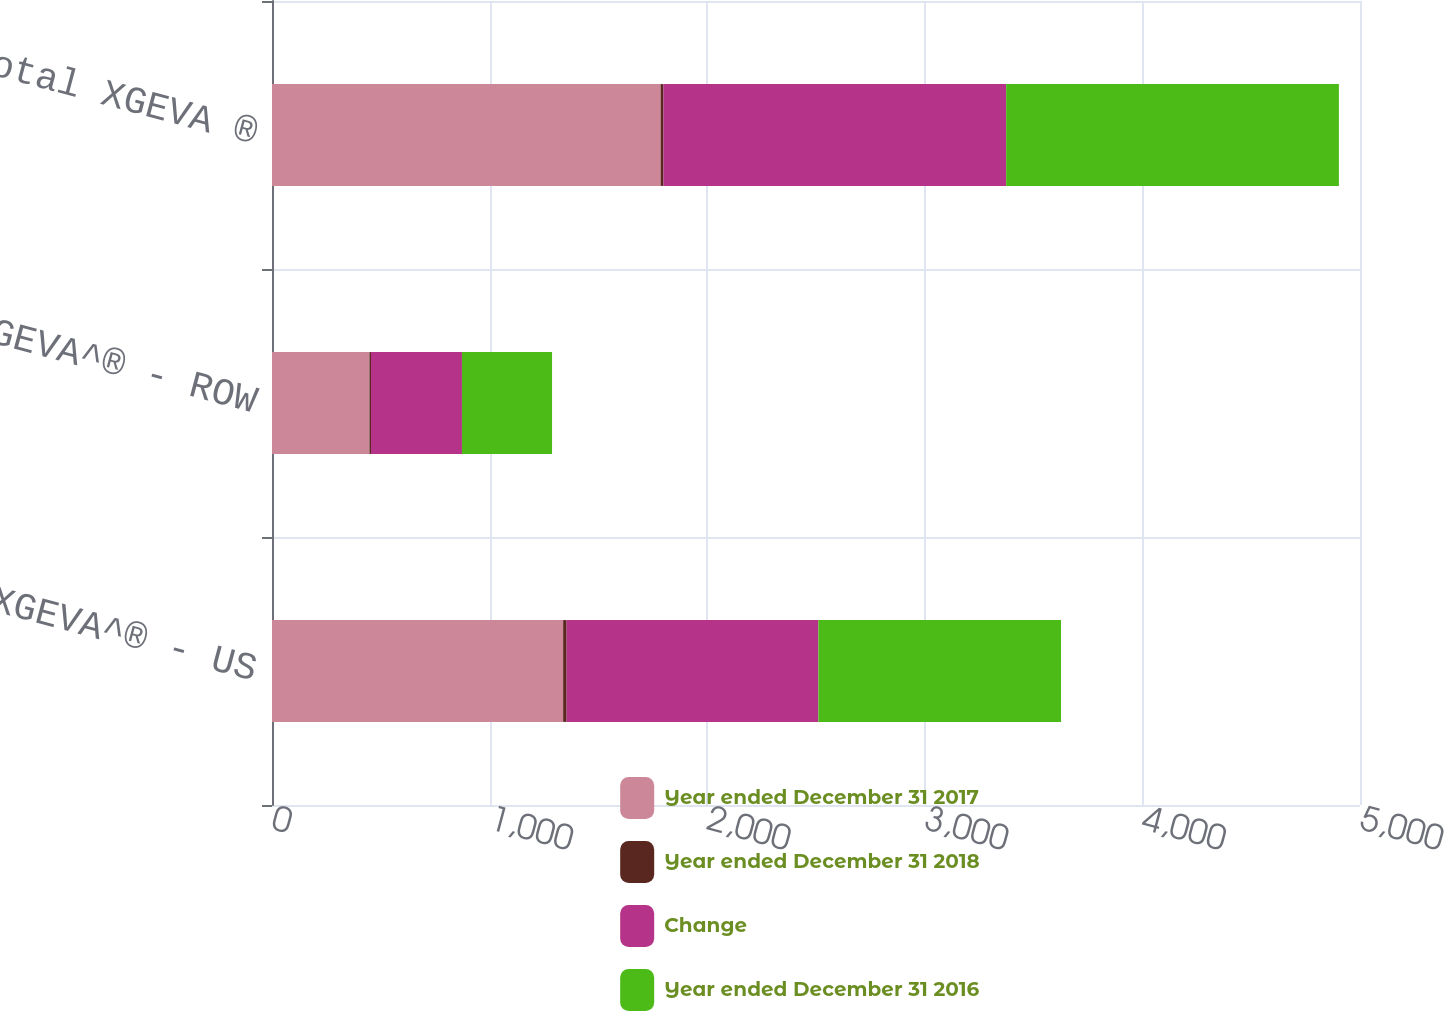Convert chart. <chart><loc_0><loc_0><loc_500><loc_500><stacked_bar_chart><ecel><fcel>XGEVA^® - US<fcel>XGEVA^® - ROW<fcel>Total XGEVA ®<nl><fcel>Year ended December 31 2017<fcel>1338<fcel>448<fcel>1786<nl><fcel>Year ended December 31 2018<fcel>16<fcel>7<fcel>13<nl><fcel>Change<fcel>1157<fcel>418<fcel>1575<nl><fcel>Year ended December 31 2016<fcel>1115<fcel>414<fcel>1529<nl></chart> 